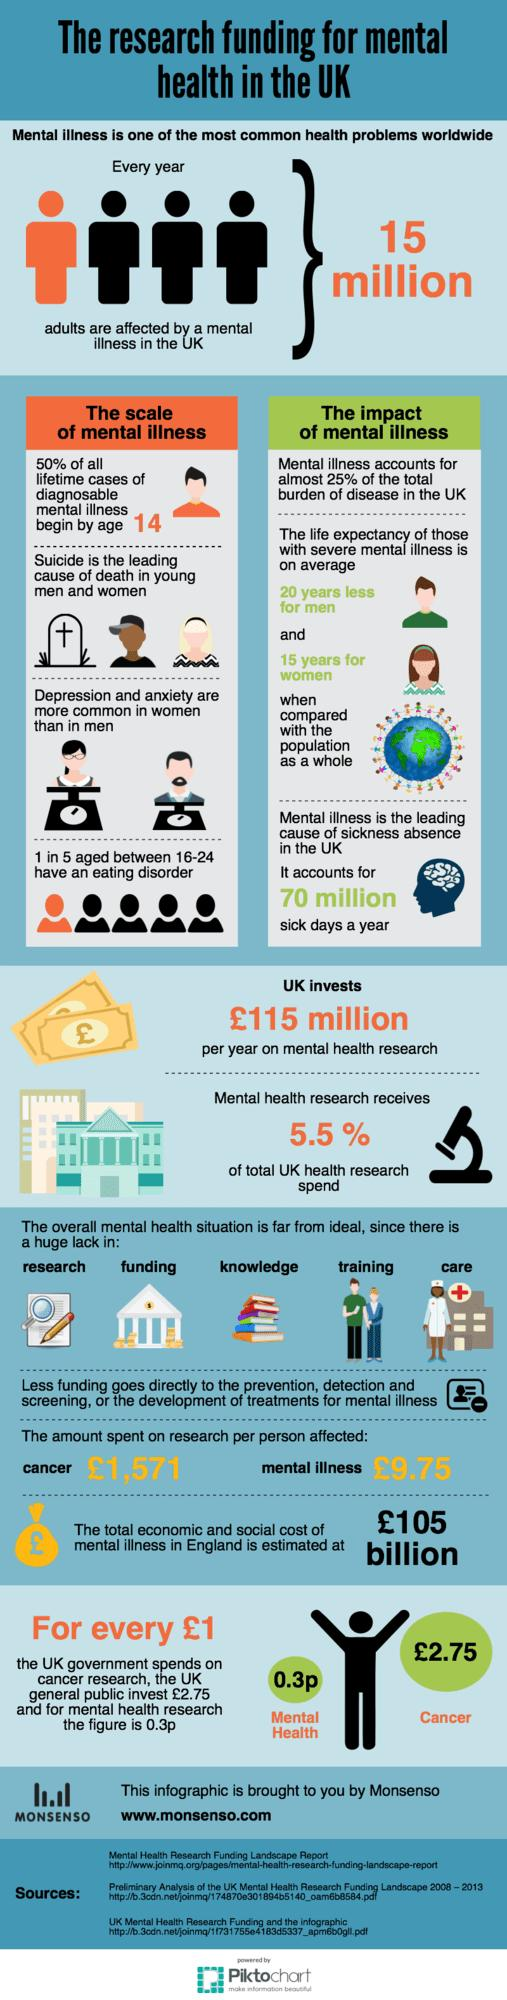Identify some key points in this picture. The amount spent on research per person for cancer is 1,561.25 pounds, while the amount spent on research per person for mental illness is... The person diagnosed with mental illness who has a lower life expectancy is men. 